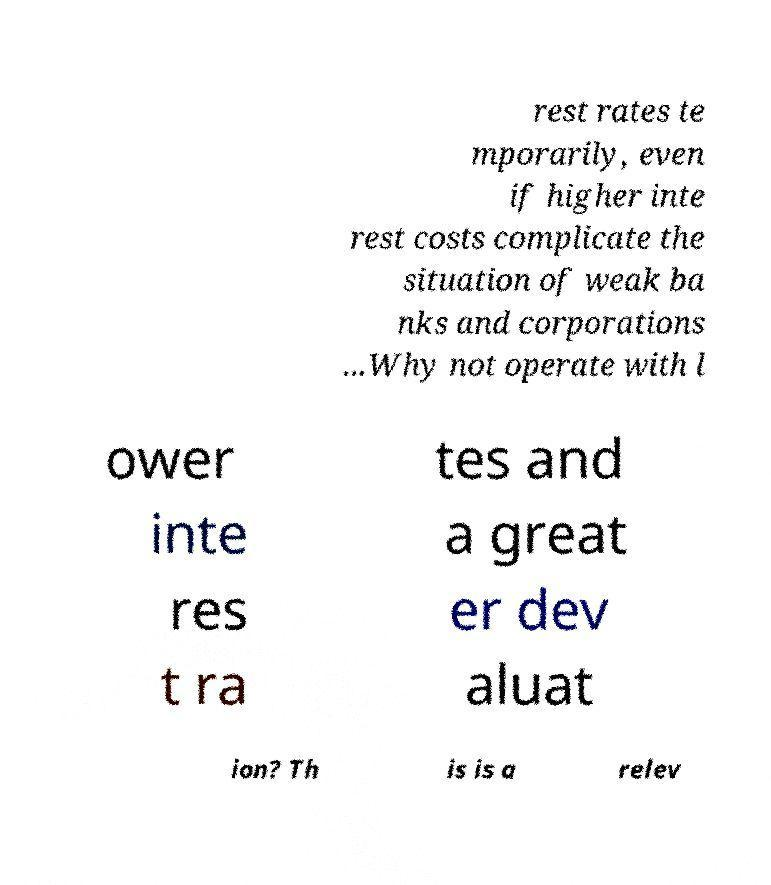Can you read and provide the text displayed in the image?This photo seems to have some interesting text. Can you extract and type it out for me? rest rates te mporarily, even if higher inte rest costs complicate the situation of weak ba nks and corporations ...Why not operate with l ower inte res t ra tes and a great er dev aluat ion? Th is is a relev 